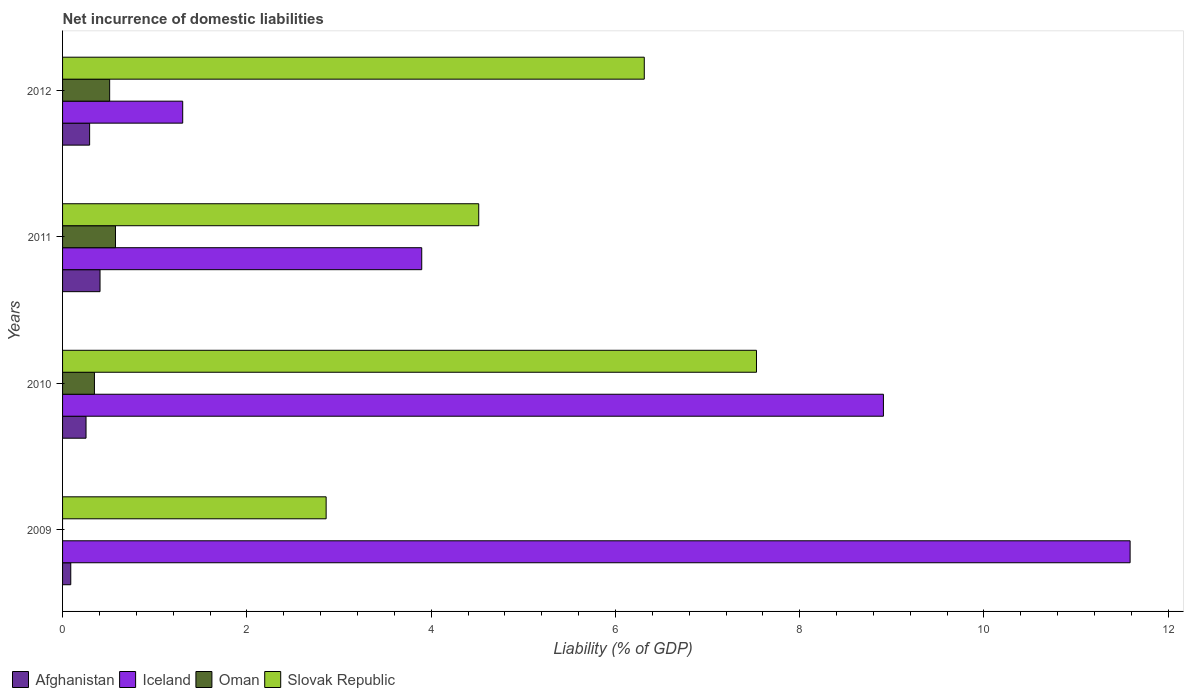How many different coloured bars are there?
Ensure brevity in your answer.  4. How many groups of bars are there?
Your answer should be compact. 4. Are the number of bars on each tick of the Y-axis equal?
Keep it short and to the point. No. How many bars are there on the 1st tick from the top?
Ensure brevity in your answer.  4. What is the net incurrence of domestic liabilities in Iceland in 2012?
Provide a short and direct response. 1.3. Across all years, what is the maximum net incurrence of domestic liabilities in Oman?
Give a very brief answer. 0.57. Across all years, what is the minimum net incurrence of domestic liabilities in Iceland?
Offer a very short reply. 1.3. In which year was the net incurrence of domestic liabilities in Afghanistan maximum?
Provide a succinct answer. 2011. What is the total net incurrence of domestic liabilities in Iceland in the graph?
Give a very brief answer. 25.7. What is the difference between the net incurrence of domestic liabilities in Afghanistan in 2009 and that in 2012?
Give a very brief answer. -0.2. What is the difference between the net incurrence of domestic liabilities in Slovak Republic in 2010 and the net incurrence of domestic liabilities in Oman in 2012?
Offer a terse response. 7.02. What is the average net incurrence of domestic liabilities in Iceland per year?
Provide a succinct answer. 6.42. In the year 2012, what is the difference between the net incurrence of domestic liabilities in Iceland and net incurrence of domestic liabilities in Slovak Republic?
Make the answer very short. -5.01. In how many years, is the net incurrence of domestic liabilities in Afghanistan greater than 8.4 %?
Keep it short and to the point. 0. What is the ratio of the net incurrence of domestic liabilities in Iceland in 2011 to that in 2012?
Your answer should be very brief. 2.99. What is the difference between the highest and the second highest net incurrence of domestic liabilities in Oman?
Your answer should be compact. 0.06. What is the difference between the highest and the lowest net incurrence of domestic liabilities in Afghanistan?
Provide a short and direct response. 0.32. Is the sum of the net incurrence of domestic liabilities in Iceland in 2010 and 2011 greater than the maximum net incurrence of domestic liabilities in Slovak Republic across all years?
Your answer should be very brief. Yes. Is it the case that in every year, the sum of the net incurrence of domestic liabilities in Oman and net incurrence of domestic liabilities in Slovak Republic is greater than the net incurrence of domestic liabilities in Iceland?
Provide a short and direct response. No. How many bars are there?
Ensure brevity in your answer.  15. How many years are there in the graph?
Provide a succinct answer. 4. What is the difference between two consecutive major ticks on the X-axis?
Your response must be concise. 2. Does the graph contain any zero values?
Your answer should be very brief. Yes. Where does the legend appear in the graph?
Keep it short and to the point. Bottom left. How many legend labels are there?
Offer a very short reply. 4. How are the legend labels stacked?
Make the answer very short. Horizontal. What is the title of the graph?
Your answer should be compact. Net incurrence of domestic liabilities. Does "Pakistan" appear as one of the legend labels in the graph?
Give a very brief answer. No. What is the label or title of the X-axis?
Provide a succinct answer. Liability (% of GDP). What is the label or title of the Y-axis?
Provide a succinct answer. Years. What is the Liability (% of GDP) of Afghanistan in 2009?
Make the answer very short. 0.09. What is the Liability (% of GDP) in Iceland in 2009?
Your response must be concise. 11.59. What is the Liability (% of GDP) of Slovak Republic in 2009?
Provide a short and direct response. 2.86. What is the Liability (% of GDP) of Afghanistan in 2010?
Make the answer very short. 0.25. What is the Liability (% of GDP) in Iceland in 2010?
Your response must be concise. 8.91. What is the Liability (% of GDP) in Oman in 2010?
Make the answer very short. 0.35. What is the Liability (% of GDP) of Slovak Republic in 2010?
Provide a succinct answer. 7.53. What is the Liability (% of GDP) in Afghanistan in 2011?
Offer a very short reply. 0.41. What is the Liability (% of GDP) of Iceland in 2011?
Your response must be concise. 3.9. What is the Liability (% of GDP) of Oman in 2011?
Your answer should be very brief. 0.57. What is the Liability (% of GDP) in Slovak Republic in 2011?
Your answer should be very brief. 4.52. What is the Liability (% of GDP) of Afghanistan in 2012?
Your answer should be compact. 0.29. What is the Liability (% of GDP) in Iceland in 2012?
Provide a succinct answer. 1.3. What is the Liability (% of GDP) of Oman in 2012?
Your answer should be compact. 0.51. What is the Liability (% of GDP) in Slovak Republic in 2012?
Make the answer very short. 6.31. Across all years, what is the maximum Liability (% of GDP) of Afghanistan?
Ensure brevity in your answer.  0.41. Across all years, what is the maximum Liability (% of GDP) of Iceland?
Give a very brief answer. 11.59. Across all years, what is the maximum Liability (% of GDP) of Oman?
Give a very brief answer. 0.57. Across all years, what is the maximum Liability (% of GDP) of Slovak Republic?
Keep it short and to the point. 7.53. Across all years, what is the minimum Liability (% of GDP) in Afghanistan?
Provide a succinct answer. 0.09. Across all years, what is the minimum Liability (% of GDP) in Iceland?
Make the answer very short. 1.3. Across all years, what is the minimum Liability (% of GDP) of Slovak Republic?
Your response must be concise. 2.86. What is the total Liability (% of GDP) of Afghanistan in the graph?
Offer a very short reply. 1.04. What is the total Liability (% of GDP) of Iceland in the graph?
Offer a terse response. 25.7. What is the total Liability (% of GDP) in Oman in the graph?
Offer a terse response. 1.43. What is the total Liability (% of GDP) in Slovak Republic in the graph?
Provide a succinct answer. 21.22. What is the difference between the Liability (% of GDP) in Afghanistan in 2009 and that in 2010?
Your answer should be compact. -0.17. What is the difference between the Liability (% of GDP) in Iceland in 2009 and that in 2010?
Offer a terse response. 2.68. What is the difference between the Liability (% of GDP) of Slovak Republic in 2009 and that in 2010?
Your response must be concise. -4.67. What is the difference between the Liability (% of GDP) of Afghanistan in 2009 and that in 2011?
Your response must be concise. -0.32. What is the difference between the Liability (% of GDP) of Iceland in 2009 and that in 2011?
Offer a terse response. 7.69. What is the difference between the Liability (% of GDP) in Slovak Republic in 2009 and that in 2011?
Give a very brief answer. -1.66. What is the difference between the Liability (% of GDP) of Afghanistan in 2009 and that in 2012?
Give a very brief answer. -0.2. What is the difference between the Liability (% of GDP) in Iceland in 2009 and that in 2012?
Make the answer very short. 10.28. What is the difference between the Liability (% of GDP) in Slovak Republic in 2009 and that in 2012?
Keep it short and to the point. -3.45. What is the difference between the Liability (% of GDP) in Afghanistan in 2010 and that in 2011?
Provide a short and direct response. -0.15. What is the difference between the Liability (% of GDP) of Iceland in 2010 and that in 2011?
Provide a short and direct response. 5.01. What is the difference between the Liability (% of GDP) of Oman in 2010 and that in 2011?
Provide a short and direct response. -0.23. What is the difference between the Liability (% of GDP) of Slovak Republic in 2010 and that in 2011?
Your response must be concise. 3.01. What is the difference between the Liability (% of GDP) of Afghanistan in 2010 and that in 2012?
Provide a short and direct response. -0.04. What is the difference between the Liability (% of GDP) in Iceland in 2010 and that in 2012?
Provide a succinct answer. 7.6. What is the difference between the Liability (% of GDP) in Oman in 2010 and that in 2012?
Offer a very short reply. -0.17. What is the difference between the Liability (% of GDP) in Slovak Republic in 2010 and that in 2012?
Ensure brevity in your answer.  1.22. What is the difference between the Liability (% of GDP) in Afghanistan in 2011 and that in 2012?
Keep it short and to the point. 0.11. What is the difference between the Liability (% of GDP) in Iceland in 2011 and that in 2012?
Give a very brief answer. 2.59. What is the difference between the Liability (% of GDP) in Oman in 2011 and that in 2012?
Your answer should be compact. 0.06. What is the difference between the Liability (% of GDP) of Slovak Republic in 2011 and that in 2012?
Offer a terse response. -1.8. What is the difference between the Liability (% of GDP) in Afghanistan in 2009 and the Liability (% of GDP) in Iceland in 2010?
Provide a succinct answer. -8.82. What is the difference between the Liability (% of GDP) in Afghanistan in 2009 and the Liability (% of GDP) in Oman in 2010?
Ensure brevity in your answer.  -0.26. What is the difference between the Liability (% of GDP) of Afghanistan in 2009 and the Liability (% of GDP) of Slovak Republic in 2010?
Ensure brevity in your answer.  -7.44. What is the difference between the Liability (% of GDP) in Iceland in 2009 and the Liability (% of GDP) in Oman in 2010?
Give a very brief answer. 11.24. What is the difference between the Liability (% of GDP) in Iceland in 2009 and the Liability (% of GDP) in Slovak Republic in 2010?
Your answer should be very brief. 4.05. What is the difference between the Liability (% of GDP) in Afghanistan in 2009 and the Liability (% of GDP) in Iceland in 2011?
Provide a short and direct response. -3.81. What is the difference between the Liability (% of GDP) in Afghanistan in 2009 and the Liability (% of GDP) in Oman in 2011?
Your answer should be very brief. -0.49. What is the difference between the Liability (% of GDP) in Afghanistan in 2009 and the Liability (% of GDP) in Slovak Republic in 2011?
Give a very brief answer. -4.43. What is the difference between the Liability (% of GDP) of Iceland in 2009 and the Liability (% of GDP) of Oman in 2011?
Provide a short and direct response. 11.01. What is the difference between the Liability (% of GDP) in Iceland in 2009 and the Liability (% of GDP) in Slovak Republic in 2011?
Your answer should be very brief. 7.07. What is the difference between the Liability (% of GDP) of Afghanistan in 2009 and the Liability (% of GDP) of Iceland in 2012?
Provide a short and direct response. -1.21. What is the difference between the Liability (% of GDP) of Afghanistan in 2009 and the Liability (% of GDP) of Oman in 2012?
Provide a short and direct response. -0.42. What is the difference between the Liability (% of GDP) in Afghanistan in 2009 and the Liability (% of GDP) in Slovak Republic in 2012?
Offer a terse response. -6.22. What is the difference between the Liability (% of GDP) in Iceland in 2009 and the Liability (% of GDP) in Oman in 2012?
Your answer should be very brief. 11.07. What is the difference between the Liability (% of GDP) of Iceland in 2009 and the Liability (% of GDP) of Slovak Republic in 2012?
Your answer should be very brief. 5.27. What is the difference between the Liability (% of GDP) of Afghanistan in 2010 and the Liability (% of GDP) of Iceland in 2011?
Offer a terse response. -3.64. What is the difference between the Liability (% of GDP) of Afghanistan in 2010 and the Liability (% of GDP) of Oman in 2011?
Your answer should be compact. -0.32. What is the difference between the Liability (% of GDP) in Afghanistan in 2010 and the Liability (% of GDP) in Slovak Republic in 2011?
Your answer should be very brief. -4.26. What is the difference between the Liability (% of GDP) in Iceland in 2010 and the Liability (% of GDP) in Oman in 2011?
Provide a succinct answer. 8.33. What is the difference between the Liability (% of GDP) of Iceland in 2010 and the Liability (% of GDP) of Slovak Republic in 2011?
Your answer should be very brief. 4.39. What is the difference between the Liability (% of GDP) in Oman in 2010 and the Liability (% of GDP) in Slovak Republic in 2011?
Provide a short and direct response. -4.17. What is the difference between the Liability (% of GDP) in Afghanistan in 2010 and the Liability (% of GDP) in Iceland in 2012?
Offer a terse response. -1.05. What is the difference between the Liability (% of GDP) in Afghanistan in 2010 and the Liability (% of GDP) in Oman in 2012?
Offer a very short reply. -0.26. What is the difference between the Liability (% of GDP) of Afghanistan in 2010 and the Liability (% of GDP) of Slovak Republic in 2012?
Your answer should be very brief. -6.06. What is the difference between the Liability (% of GDP) in Iceland in 2010 and the Liability (% of GDP) in Oman in 2012?
Keep it short and to the point. 8.4. What is the difference between the Liability (% of GDP) in Iceland in 2010 and the Liability (% of GDP) in Slovak Republic in 2012?
Make the answer very short. 2.6. What is the difference between the Liability (% of GDP) of Oman in 2010 and the Liability (% of GDP) of Slovak Republic in 2012?
Give a very brief answer. -5.97. What is the difference between the Liability (% of GDP) of Afghanistan in 2011 and the Liability (% of GDP) of Iceland in 2012?
Your response must be concise. -0.9. What is the difference between the Liability (% of GDP) of Afghanistan in 2011 and the Liability (% of GDP) of Oman in 2012?
Provide a short and direct response. -0.1. What is the difference between the Liability (% of GDP) of Afghanistan in 2011 and the Liability (% of GDP) of Slovak Republic in 2012?
Offer a terse response. -5.91. What is the difference between the Liability (% of GDP) of Iceland in 2011 and the Liability (% of GDP) of Oman in 2012?
Your answer should be compact. 3.39. What is the difference between the Liability (% of GDP) of Iceland in 2011 and the Liability (% of GDP) of Slovak Republic in 2012?
Keep it short and to the point. -2.42. What is the difference between the Liability (% of GDP) in Oman in 2011 and the Liability (% of GDP) in Slovak Republic in 2012?
Ensure brevity in your answer.  -5.74. What is the average Liability (% of GDP) in Afghanistan per year?
Make the answer very short. 0.26. What is the average Liability (% of GDP) of Iceland per year?
Offer a terse response. 6.42. What is the average Liability (% of GDP) of Oman per year?
Your answer should be compact. 0.36. What is the average Liability (% of GDP) of Slovak Republic per year?
Give a very brief answer. 5.31. In the year 2009, what is the difference between the Liability (% of GDP) of Afghanistan and Liability (% of GDP) of Iceland?
Provide a succinct answer. -11.5. In the year 2009, what is the difference between the Liability (% of GDP) of Afghanistan and Liability (% of GDP) of Slovak Republic?
Provide a short and direct response. -2.77. In the year 2009, what is the difference between the Liability (% of GDP) of Iceland and Liability (% of GDP) of Slovak Republic?
Give a very brief answer. 8.73. In the year 2010, what is the difference between the Liability (% of GDP) of Afghanistan and Liability (% of GDP) of Iceland?
Your answer should be very brief. -8.65. In the year 2010, what is the difference between the Liability (% of GDP) of Afghanistan and Liability (% of GDP) of Oman?
Your answer should be compact. -0.09. In the year 2010, what is the difference between the Liability (% of GDP) of Afghanistan and Liability (% of GDP) of Slovak Republic?
Offer a very short reply. -7.28. In the year 2010, what is the difference between the Liability (% of GDP) in Iceland and Liability (% of GDP) in Oman?
Give a very brief answer. 8.56. In the year 2010, what is the difference between the Liability (% of GDP) in Iceland and Liability (% of GDP) in Slovak Republic?
Ensure brevity in your answer.  1.38. In the year 2010, what is the difference between the Liability (% of GDP) of Oman and Liability (% of GDP) of Slovak Republic?
Provide a short and direct response. -7.18. In the year 2011, what is the difference between the Liability (% of GDP) in Afghanistan and Liability (% of GDP) in Iceland?
Your answer should be compact. -3.49. In the year 2011, what is the difference between the Liability (% of GDP) in Afghanistan and Liability (% of GDP) in Oman?
Ensure brevity in your answer.  -0.17. In the year 2011, what is the difference between the Liability (% of GDP) of Afghanistan and Liability (% of GDP) of Slovak Republic?
Offer a terse response. -4.11. In the year 2011, what is the difference between the Liability (% of GDP) in Iceland and Liability (% of GDP) in Oman?
Ensure brevity in your answer.  3.32. In the year 2011, what is the difference between the Liability (% of GDP) of Iceland and Liability (% of GDP) of Slovak Republic?
Offer a very short reply. -0.62. In the year 2011, what is the difference between the Liability (% of GDP) of Oman and Liability (% of GDP) of Slovak Republic?
Ensure brevity in your answer.  -3.94. In the year 2012, what is the difference between the Liability (% of GDP) in Afghanistan and Liability (% of GDP) in Iceland?
Give a very brief answer. -1.01. In the year 2012, what is the difference between the Liability (% of GDP) in Afghanistan and Liability (% of GDP) in Oman?
Make the answer very short. -0.22. In the year 2012, what is the difference between the Liability (% of GDP) in Afghanistan and Liability (% of GDP) in Slovak Republic?
Provide a succinct answer. -6.02. In the year 2012, what is the difference between the Liability (% of GDP) in Iceland and Liability (% of GDP) in Oman?
Your answer should be compact. 0.79. In the year 2012, what is the difference between the Liability (% of GDP) of Iceland and Liability (% of GDP) of Slovak Republic?
Your answer should be compact. -5.01. In the year 2012, what is the difference between the Liability (% of GDP) in Oman and Liability (% of GDP) in Slovak Republic?
Offer a terse response. -5.8. What is the ratio of the Liability (% of GDP) in Afghanistan in 2009 to that in 2010?
Give a very brief answer. 0.35. What is the ratio of the Liability (% of GDP) in Iceland in 2009 to that in 2010?
Ensure brevity in your answer.  1.3. What is the ratio of the Liability (% of GDP) in Slovak Republic in 2009 to that in 2010?
Give a very brief answer. 0.38. What is the ratio of the Liability (% of GDP) in Afghanistan in 2009 to that in 2011?
Your answer should be very brief. 0.22. What is the ratio of the Liability (% of GDP) in Iceland in 2009 to that in 2011?
Provide a short and direct response. 2.97. What is the ratio of the Liability (% of GDP) in Slovak Republic in 2009 to that in 2011?
Provide a succinct answer. 0.63. What is the ratio of the Liability (% of GDP) in Afghanistan in 2009 to that in 2012?
Your answer should be compact. 0.3. What is the ratio of the Liability (% of GDP) in Iceland in 2009 to that in 2012?
Keep it short and to the point. 8.89. What is the ratio of the Liability (% of GDP) of Slovak Republic in 2009 to that in 2012?
Make the answer very short. 0.45. What is the ratio of the Liability (% of GDP) in Afghanistan in 2010 to that in 2011?
Your response must be concise. 0.63. What is the ratio of the Liability (% of GDP) of Iceland in 2010 to that in 2011?
Your answer should be compact. 2.29. What is the ratio of the Liability (% of GDP) of Oman in 2010 to that in 2011?
Your answer should be very brief. 0.6. What is the ratio of the Liability (% of GDP) of Slovak Republic in 2010 to that in 2011?
Provide a short and direct response. 1.67. What is the ratio of the Liability (% of GDP) of Afghanistan in 2010 to that in 2012?
Keep it short and to the point. 0.87. What is the ratio of the Liability (% of GDP) in Iceland in 2010 to that in 2012?
Your answer should be very brief. 6.83. What is the ratio of the Liability (% of GDP) in Oman in 2010 to that in 2012?
Your answer should be very brief. 0.68. What is the ratio of the Liability (% of GDP) of Slovak Republic in 2010 to that in 2012?
Ensure brevity in your answer.  1.19. What is the ratio of the Liability (% of GDP) in Afghanistan in 2011 to that in 2012?
Keep it short and to the point. 1.38. What is the ratio of the Liability (% of GDP) in Iceland in 2011 to that in 2012?
Give a very brief answer. 2.99. What is the ratio of the Liability (% of GDP) of Oman in 2011 to that in 2012?
Ensure brevity in your answer.  1.12. What is the ratio of the Liability (% of GDP) in Slovak Republic in 2011 to that in 2012?
Your response must be concise. 0.72. What is the difference between the highest and the second highest Liability (% of GDP) in Afghanistan?
Provide a short and direct response. 0.11. What is the difference between the highest and the second highest Liability (% of GDP) in Iceland?
Provide a short and direct response. 2.68. What is the difference between the highest and the second highest Liability (% of GDP) in Oman?
Your response must be concise. 0.06. What is the difference between the highest and the second highest Liability (% of GDP) of Slovak Republic?
Offer a terse response. 1.22. What is the difference between the highest and the lowest Liability (% of GDP) in Afghanistan?
Give a very brief answer. 0.32. What is the difference between the highest and the lowest Liability (% of GDP) in Iceland?
Ensure brevity in your answer.  10.28. What is the difference between the highest and the lowest Liability (% of GDP) in Oman?
Ensure brevity in your answer.  0.57. What is the difference between the highest and the lowest Liability (% of GDP) of Slovak Republic?
Your answer should be compact. 4.67. 